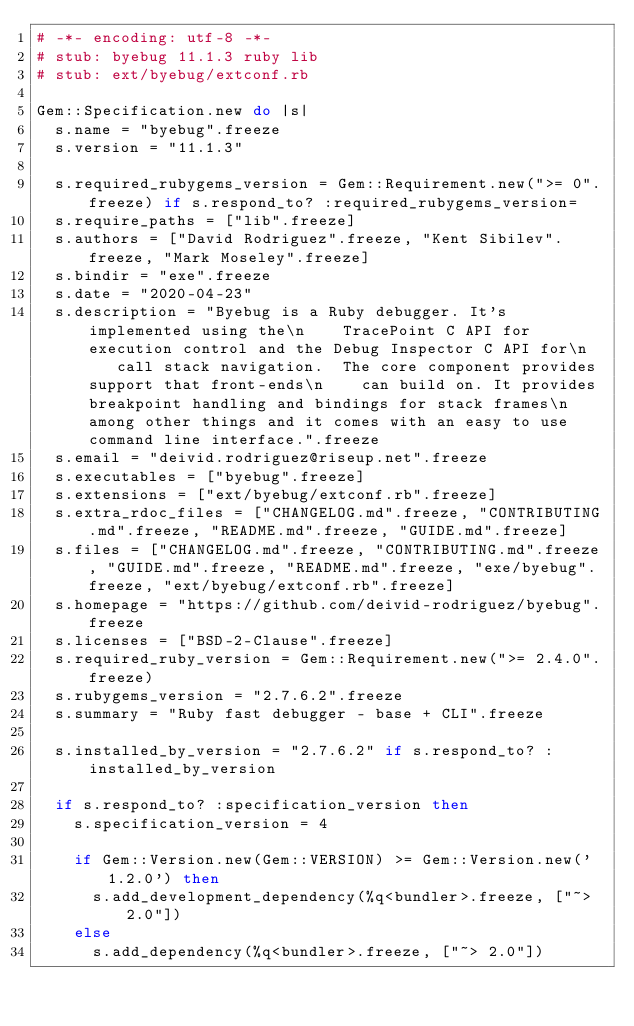Convert code to text. <code><loc_0><loc_0><loc_500><loc_500><_Ruby_># -*- encoding: utf-8 -*-
# stub: byebug 11.1.3 ruby lib
# stub: ext/byebug/extconf.rb

Gem::Specification.new do |s|
  s.name = "byebug".freeze
  s.version = "11.1.3"

  s.required_rubygems_version = Gem::Requirement.new(">= 0".freeze) if s.respond_to? :required_rubygems_version=
  s.require_paths = ["lib".freeze]
  s.authors = ["David Rodriguez".freeze, "Kent Sibilev".freeze, "Mark Moseley".freeze]
  s.bindir = "exe".freeze
  s.date = "2020-04-23"
  s.description = "Byebug is a Ruby debugger. It's implemented using the\n    TracePoint C API for execution control and the Debug Inspector C API for\n    call stack navigation.  The core component provides support that front-ends\n    can build on. It provides breakpoint handling and bindings for stack frames\n    among other things and it comes with an easy to use command line interface.".freeze
  s.email = "deivid.rodriguez@riseup.net".freeze
  s.executables = ["byebug".freeze]
  s.extensions = ["ext/byebug/extconf.rb".freeze]
  s.extra_rdoc_files = ["CHANGELOG.md".freeze, "CONTRIBUTING.md".freeze, "README.md".freeze, "GUIDE.md".freeze]
  s.files = ["CHANGELOG.md".freeze, "CONTRIBUTING.md".freeze, "GUIDE.md".freeze, "README.md".freeze, "exe/byebug".freeze, "ext/byebug/extconf.rb".freeze]
  s.homepage = "https://github.com/deivid-rodriguez/byebug".freeze
  s.licenses = ["BSD-2-Clause".freeze]
  s.required_ruby_version = Gem::Requirement.new(">= 2.4.0".freeze)
  s.rubygems_version = "2.7.6.2".freeze
  s.summary = "Ruby fast debugger - base + CLI".freeze

  s.installed_by_version = "2.7.6.2" if s.respond_to? :installed_by_version

  if s.respond_to? :specification_version then
    s.specification_version = 4

    if Gem::Version.new(Gem::VERSION) >= Gem::Version.new('1.2.0') then
      s.add_development_dependency(%q<bundler>.freeze, ["~> 2.0"])
    else
      s.add_dependency(%q<bundler>.freeze, ["~> 2.0"])</code> 